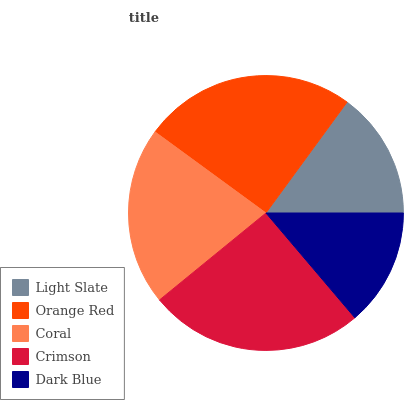Is Dark Blue the minimum?
Answer yes or no. Yes. Is Crimson the maximum?
Answer yes or no. Yes. Is Orange Red the minimum?
Answer yes or no. No. Is Orange Red the maximum?
Answer yes or no. No. Is Orange Red greater than Light Slate?
Answer yes or no. Yes. Is Light Slate less than Orange Red?
Answer yes or no. Yes. Is Light Slate greater than Orange Red?
Answer yes or no. No. Is Orange Red less than Light Slate?
Answer yes or no. No. Is Coral the high median?
Answer yes or no. Yes. Is Coral the low median?
Answer yes or no. Yes. Is Light Slate the high median?
Answer yes or no. No. Is Light Slate the low median?
Answer yes or no. No. 